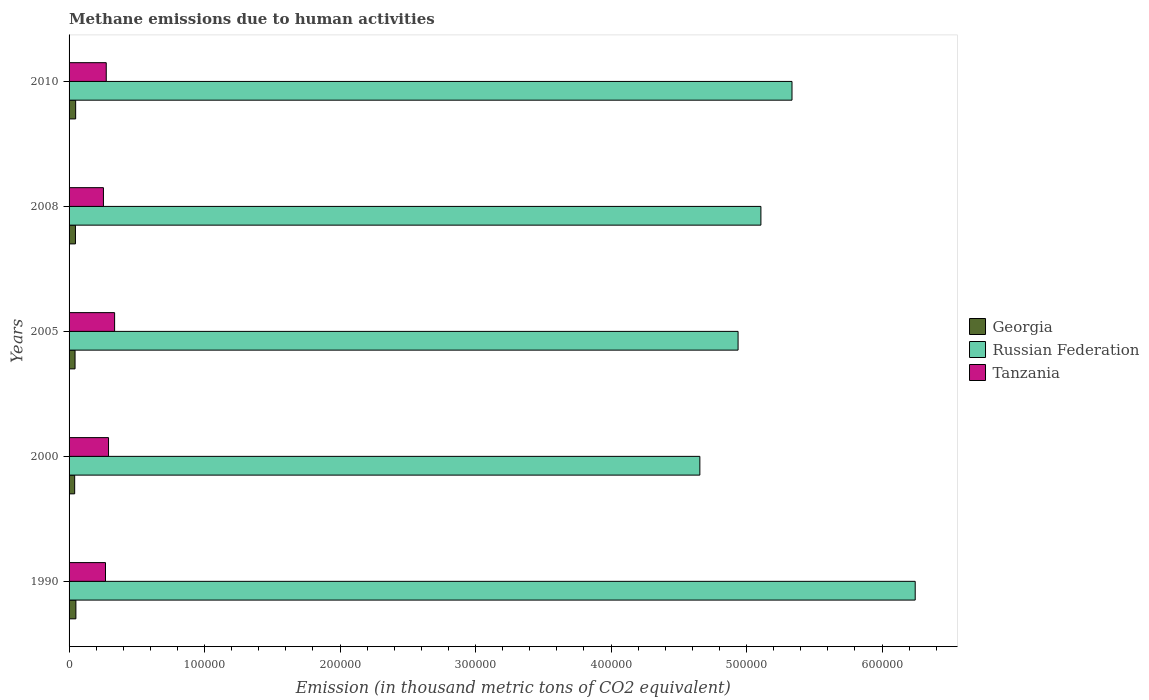How many groups of bars are there?
Offer a very short reply. 5. How many bars are there on the 5th tick from the top?
Give a very brief answer. 3. What is the amount of methane emitted in Russian Federation in 2005?
Provide a short and direct response. 4.94e+05. Across all years, what is the maximum amount of methane emitted in Georgia?
Provide a succinct answer. 5037. Across all years, what is the minimum amount of methane emitted in Georgia?
Offer a terse response. 4137.4. In which year was the amount of methane emitted in Tanzania maximum?
Provide a short and direct response. 2005. In which year was the amount of methane emitted in Russian Federation minimum?
Offer a very short reply. 2000. What is the total amount of methane emitted in Tanzania in the graph?
Offer a very short reply. 1.42e+05. What is the difference between the amount of methane emitted in Tanzania in 1990 and that in 2005?
Your response must be concise. -6719. What is the difference between the amount of methane emitted in Tanzania in 2005 and the amount of methane emitted in Georgia in 2000?
Offer a very short reply. 2.95e+04. What is the average amount of methane emitted in Tanzania per year?
Your answer should be very brief. 2.85e+04. In the year 2000, what is the difference between the amount of methane emitted in Tanzania and amount of methane emitted in Russian Federation?
Offer a terse response. -4.36e+05. In how many years, is the amount of methane emitted in Georgia greater than 340000 thousand metric tons?
Keep it short and to the point. 0. What is the ratio of the amount of methane emitted in Russian Federation in 1990 to that in 2008?
Provide a succinct answer. 1.22. Is the amount of methane emitted in Tanzania in 2000 less than that in 2005?
Your response must be concise. Yes. Is the difference between the amount of methane emitted in Tanzania in 2005 and 2010 greater than the difference between the amount of methane emitted in Russian Federation in 2005 and 2010?
Offer a very short reply. Yes. What is the difference between the highest and the second highest amount of methane emitted in Georgia?
Make the answer very short. 173.5. What is the difference between the highest and the lowest amount of methane emitted in Georgia?
Make the answer very short. 899.6. In how many years, is the amount of methane emitted in Russian Federation greater than the average amount of methane emitted in Russian Federation taken over all years?
Make the answer very short. 2. Is the sum of the amount of methane emitted in Russian Federation in 2000 and 2010 greater than the maximum amount of methane emitted in Tanzania across all years?
Your answer should be compact. Yes. What does the 3rd bar from the top in 2005 represents?
Offer a terse response. Georgia. What does the 3rd bar from the bottom in 2000 represents?
Your answer should be very brief. Tanzania. Is it the case that in every year, the sum of the amount of methane emitted in Tanzania and amount of methane emitted in Russian Federation is greater than the amount of methane emitted in Georgia?
Keep it short and to the point. Yes. How many years are there in the graph?
Provide a succinct answer. 5. Does the graph contain any zero values?
Keep it short and to the point. No. Does the graph contain grids?
Give a very brief answer. No. How many legend labels are there?
Keep it short and to the point. 3. What is the title of the graph?
Your answer should be compact. Methane emissions due to human activities. What is the label or title of the X-axis?
Offer a terse response. Emission (in thousand metric tons of CO2 equivalent). What is the Emission (in thousand metric tons of CO2 equivalent) of Georgia in 1990?
Your answer should be very brief. 5037. What is the Emission (in thousand metric tons of CO2 equivalent) of Russian Federation in 1990?
Give a very brief answer. 6.24e+05. What is the Emission (in thousand metric tons of CO2 equivalent) in Tanzania in 1990?
Your answer should be very brief. 2.69e+04. What is the Emission (in thousand metric tons of CO2 equivalent) in Georgia in 2000?
Your answer should be very brief. 4137.4. What is the Emission (in thousand metric tons of CO2 equivalent) of Russian Federation in 2000?
Offer a very short reply. 4.66e+05. What is the Emission (in thousand metric tons of CO2 equivalent) of Tanzania in 2000?
Provide a short and direct response. 2.91e+04. What is the Emission (in thousand metric tons of CO2 equivalent) of Georgia in 2005?
Your answer should be compact. 4413.2. What is the Emission (in thousand metric tons of CO2 equivalent) of Russian Federation in 2005?
Offer a very short reply. 4.94e+05. What is the Emission (in thousand metric tons of CO2 equivalent) of Tanzania in 2005?
Ensure brevity in your answer.  3.36e+04. What is the Emission (in thousand metric tons of CO2 equivalent) of Georgia in 2008?
Give a very brief answer. 4708.2. What is the Emission (in thousand metric tons of CO2 equivalent) in Russian Federation in 2008?
Keep it short and to the point. 5.11e+05. What is the Emission (in thousand metric tons of CO2 equivalent) of Tanzania in 2008?
Make the answer very short. 2.54e+04. What is the Emission (in thousand metric tons of CO2 equivalent) of Georgia in 2010?
Give a very brief answer. 4863.5. What is the Emission (in thousand metric tons of CO2 equivalent) of Russian Federation in 2010?
Your answer should be compact. 5.34e+05. What is the Emission (in thousand metric tons of CO2 equivalent) of Tanzania in 2010?
Ensure brevity in your answer.  2.74e+04. Across all years, what is the maximum Emission (in thousand metric tons of CO2 equivalent) of Georgia?
Give a very brief answer. 5037. Across all years, what is the maximum Emission (in thousand metric tons of CO2 equivalent) of Russian Federation?
Offer a terse response. 6.24e+05. Across all years, what is the maximum Emission (in thousand metric tons of CO2 equivalent) of Tanzania?
Your answer should be very brief. 3.36e+04. Across all years, what is the minimum Emission (in thousand metric tons of CO2 equivalent) of Georgia?
Your answer should be compact. 4137.4. Across all years, what is the minimum Emission (in thousand metric tons of CO2 equivalent) of Russian Federation?
Your answer should be compact. 4.66e+05. Across all years, what is the minimum Emission (in thousand metric tons of CO2 equivalent) of Tanzania?
Make the answer very short. 2.54e+04. What is the total Emission (in thousand metric tons of CO2 equivalent) of Georgia in the graph?
Your response must be concise. 2.32e+04. What is the total Emission (in thousand metric tons of CO2 equivalent) in Russian Federation in the graph?
Provide a short and direct response. 2.63e+06. What is the total Emission (in thousand metric tons of CO2 equivalent) in Tanzania in the graph?
Keep it short and to the point. 1.42e+05. What is the difference between the Emission (in thousand metric tons of CO2 equivalent) of Georgia in 1990 and that in 2000?
Offer a terse response. 899.6. What is the difference between the Emission (in thousand metric tons of CO2 equivalent) in Russian Federation in 1990 and that in 2000?
Offer a terse response. 1.59e+05. What is the difference between the Emission (in thousand metric tons of CO2 equivalent) in Tanzania in 1990 and that in 2000?
Your answer should be very brief. -2232.7. What is the difference between the Emission (in thousand metric tons of CO2 equivalent) in Georgia in 1990 and that in 2005?
Your response must be concise. 623.8. What is the difference between the Emission (in thousand metric tons of CO2 equivalent) of Russian Federation in 1990 and that in 2005?
Offer a very short reply. 1.31e+05. What is the difference between the Emission (in thousand metric tons of CO2 equivalent) of Tanzania in 1990 and that in 2005?
Offer a terse response. -6719. What is the difference between the Emission (in thousand metric tons of CO2 equivalent) of Georgia in 1990 and that in 2008?
Your answer should be compact. 328.8. What is the difference between the Emission (in thousand metric tons of CO2 equivalent) in Russian Federation in 1990 and that in 2008?
Provide a short and direct response. 1.14e+05. What is the difference between the Emission (in thousand metric tons of CO2 equivalent) of Tanzania in 1990 and that in 2008?
Ensure brevity in your answer.  1531.3. What is the difference between the Emission (in thousand metric tons of CO2 equivalent) in Georgia in 1990 and that in 2010?
Provide a short and direct response. 173.5. What is the difference between the Emission (in thousand metric tons of CO2 equivalent) of Russian Federation in 1990 and that in 2010?
Give a very brief answer. 9.09e+04. What is the difference between the Emission (in thousand metric tons of CO2 equivalent) of Tanzania in 1990 and that in 2010?
Your answer should be compact. -554.2. What is the difference between the Emission (in thousand metric tons of CO2 equivalent) in Georgia in 2000 and that in 2005?
Your answer should be compact. -275.8. What is the difference between the Emission (in thousand metric tons of CO2 equivalent) of Russian Federation in 2000 and that in 2005?
Make the answer very short. -2.82e+04. What is the difference between the Emission (in thousand metric tons of CO2 equivalent) of Tanzania in 2000 and that in 2005?
Your response must be concise. -4486.3. What is the difference between the Emission (in thousand metric tons of CO2 equivalent) of Georgia in 2000 and that in 2008?
Offer a terse response. -570.8. What is the difference between the Emission (in thousand metric tons of CO2 equivalent) in Russian Federation in 2000 and that in 2008?
Your response must be concise. -4.51e+04. What is the difference between the Emission (in thousand metric tons of CO2 equivalent) of Tanzania in 2000 and that in 2008?
Your answer should be compact. 3764. What is the difference between the Emission (in thousand metric tons of CO2 equivalent) in Georgia in 2000 and that in 2010?
Provide a short and direct response. -726.1. What is the difference between the Emission (in thousand metric tons of CO2 equivalent) in Russian Federation in 2000 and that in 2010?
Offer a terse response. -6.80e+04. What is the difference between the Emission (in thousand metric tons of CO2 equivalent) in Tanzania in 2000 and that in 2010?
Provide a succinct answer. 1678.5. What is the difference between the Emission (in thousand metric tons of CO2 equivalent) in Georgia in 2005 and that in 2008?
Provide a succinct answer. -295. What is the difference between the Emission (in thousand metric tons of CO2 equivalent) of Russian Federation in 2005 and that in 2008?
Provide a succinct answer. -1.69e+04. What is the difference between the Emission (in thousand metric tons of CO2 equivalent) of Tanzania in 2005 and that in 2008?
Make the answer very short. 8250.3. What is the difference between the Emission (in thousand metric tons of CO2 equivalent) of Georgia in 2005 and that in 2010?
Your response must be concise. -450.3. What is the difference between the Emission (in thousand metric tons of CO2 equivalent) in Russian Federation in 2005 and that in 2010?
Give a very brief answer. -3.98e+04. What is the difference between the Emission (in thousand metric tons of CO2 equivalent) in Tanzania in 2005 and that in 2010?
Provide a short and direct response. 6164.8. What is the difference between the Emission (in thousand metric tons of CO2 equivalent) of Georgia in 2008 and that in 2010?
Offer a very short reply. -155.3. What is the difference between the Emission (in thousand metric tons of CO2 equivalent) of Russian Federation in 2008 and that in 2010?
Give a very brief answer. -2.29e+04. What is the difference between the Emission (in thousand metric tons of CO2 equivalent) of Tanzania in 2008 and that in 2010?
Your response must be concise. -2085.5. What is the difference between the Emission (in thousand metric tons of CO2 equivalent) of Georgia in 1990 and the Emission (in thousand metric tons of CO2 equivalent) of Russian Federation in 2000?
Offer a very short reply. -4.61e+05. What is the difference between the Emission (in thousand metric tons of CO2 equivalent) of Georgia in 1990 and the Emission (in thousand metric tons of CO2 equivalent) of Tanzania in 2000?
Provide a short and direct response. -2.41e+04. What is the difference between the Emission (in thousand metric tons of CO2 equivalent) in Russian Federation in 1990 and the Emission (in thousand metric tons of CO2 equivalent) in Tanzania in 2000?
Your answer should be very brief. 5.95e+05. What is the difference between the Emission (in thousand metric tons of CO2 equivalent) of Georgia in 1990 and the Emission (in thousand metric tons of CO2 equivalent) of Russian Federation in 2005?
Keep it short and to the point. -4.89e+05. What is the difference between the Emission (in thousand metric tons of CO2 equivalent) of Georgia in 1990 and the Emission (in thousand metric tons of CO2 equivalent) of Tanzania in 2005?
Provide a succinct answer. -2.86e+04. What is the difference between the Emission (in thousand metric tons of CO2 equivalent) in Russian Federation in 1990 and the Emission (in thousand metric tons of CO2 equivalent) in Tanzania in 2005?
Provide a succinct answer. 5.91e+05. What is the difference between the Emission (in thousand metric tons of CO2 equivalent) in Georgia in 1990 and the Emission (in thousand metric tons of CO2 equivalent) in Russian Federation in 2008?
Offer a terse response. -5.06e+05. What is the difference between the Emission (in thousand metric tons of CO2 equivalent) in Georgia in 1990 and the Emission (in thousand metric tons of CO2 equivalent) in Tanzania in 2008?
Make the answer very short. -2.03e+04. What is the difference between the Emission (in thousand metric tons of CO2 equivalent) of Russian Federation in 1990 and the Emission (in thousand metric tons of CO2 equivalent) of Tanzania in 2008?
Your response must be concise. 5.99e+05. What is the difference between the Emission (in thousand metric tons of CO2 equivalent) in Georgia in 1990 and the Emission (in thousand metric tons of CO2 equivalent) in Russian Federation in 2010?
Provide a short and direct response. -5.29e+05. What is the difference between the Emission (in thousand metric tons of CO2 equivalent) in Georgia in 1990 and the Emission (in thousand metric tons of CO2 equivalent) in Tanzania in 2010?
Provide a short and direct response. -2.24e+04. What is the difference between the Emission (in thousand metric tons of CO2 equivalent) of Russian Federation in 1990 and the Emission (in thousand metric tons of CO2 equivalent) of Tanzania in 2010?
Give a very brief answer. 5.97e+05. What is the difference between the Emission (in thousand metric tons of CO2 equivalent) in Georgia in 2000 and the Emission (in thousand metric tons of CO2 equivalent) in Russian Federation in 2005?
Make the answer very short. -4.90e+05. What is the difference between the Emission (in thousand metric tons of CO2 equivalent) in Georgia in 2000 and the Emission (in thousand metric tons of CO2 equivalent) in Tanzania in 2005?
Provide a short and direct response. -2.95e+04. What is the difference between the Emission (in thousand metric tons of CO2 equivalent) in Russian Federation in 2000 and the Emission (in thousand metric tons of CO2 equivalent) in Tanzania in 2005?
Your answer should be very brief. 4.32e+05. What is the difference between the Emission (in thousand metric tons of CO2 equivalent) of Georgia in 2000 and the Emission (in thousand metric tons of CO2 equivalent) of Russian Federation in 2008?
Make the answer very short. -5.06e+05. What is the difference between the Emission (in thousand metric tons of CO2 equivalent) in Georgia in 2000 and the Emission (in thousand metric tons of CO2 equivalent) in Tanzania in 2008?
Provide a succinct answer. -2.12e+04. What is the difference between the Emission (in thousand metric tons of CO2 equivalent) of Russian Federation in 2000 and the Emission (in thousand metric tons of CO2 equivalent) of Tanzania in 2008?
Offer a terse response. 4.40e+05. What is the difference between the Emission (in thousand metric tons of CO2 equivalent) in Georgia in 2000 and the Emission (in thousand metric tons of CO2 equivalent) in Russian Federation in 2010?
Offer a very short reply. -5.29e+05. What is the difference between the Emission (in thousand metric tons of CO2 equivalent) of Georgia in 2000 and the Emission (in thousand metric tons of CO2 equivalent) of Tanzania in 2010?
Your answer should be compact. -2.33e+04. What is the difference between the Emission (in thousand metric tons of CO2 equivalent) in Russian Federation in 2000 and the Emission (in thousand metric tons of CO2 equivalent) in Tanzania in 2010?
Give a very brief answer. 4.38e+05. What is the difference between the Emission (in thousand metric tons of CO2 equivalent) of Georgia in 2005 and the Emission (in thousand metric tons of CO2 equivalent) of Russian Federation in 2008?
Offer a very short reply. -5.06e+05. What is the difference between the Emission (in thousand metric tons of CO2 equivalent) of Georgia in 2005 and the Emission (in thousand metric tons of CO2 equivalent) of Tanzania in 2008?
Keep it short and to the point. -2.09e+04. What is the difference between the Emission (in thousand metric tons of CO2 equivalent) in Russian Federation in 2005 and the Emission (in thousand metric tons of CO2 equivalent) in Tanzania in 2008?
Your answer should be very brief. 4.68e+05. What is the difference between the Emission (in thousand metric tons of CO2 equivalent) of Georgia in 2005 and the Emission (in thousand metric tons of CO2 equivalent) of Russian Federation in 2010?
Offer a terse response. -5.29e+05. What is the difference between the Emission (in thousand metric tons of CO2 equivalent) in Georgia in 2005 and the Emission (in thousand metric tons of CO2 equivalent) in Tanzania in 2010?
Keep it short and to the point. -2.30e+04. What is the difference between the Emission (in thousand metric tons of CO2 equivalent) of Russian Federation in 2005 and the Emission (in thousand metric tons of CO2 equivalent) of Tanzania in 2010?
Keep it short and to the point. 4.66e+05. What is the difference between the Emission (in thousand metric tons of CO2 equivalent) in Georgia in 2008 and the Emission (in thousand metric tons of CO2 equivalent) in Russian Federation in 2010?
Give a very brief answer. -5.29e+05. What is the difference between the Emission (in thousand metric tons of CO2 equivalent) in Georgia in 2008 and the Emission (in thousand metric tons of CO2 equivalent) in Tanzania in 2010?
Keep it short and to the point. -2.27e+04. What is the difference between the Emission (in thousand metric tons of CO2 equivalent) in Russian Federation in 2008 and the Emission (in thousand metric tons of CO2 equivalent) in Tanzania in 2010?
Keep it short and to the point. 4.83e+05. What is the average Emission (in thousand metric tons of CO2 equivalent) of Georgia per year?
Keep it short and to the point. 4631.86. What is the average Emission (in thousand metric tons of CO2 equivalent) of Russian Federation per year?
Give a very brief answer. 5.26e+05. What is the average Emission (in thousand metric tons of CO2 equivalent) of Tanzania per year?
Your answer should be compact. 2.85e+04. In the year 1990, what is the difference between the Emission (in thousand metric tons of CO2 equivalent) of Georgia and Emission (in thousand metric tons of CO2 equivalent) of Russian Federation?
Offer a very short reply. -6.19e+05. In the year 1990, what is the difference between the Emission (in thousand metric tons of CO2 equivalent) of Georgia and Emission (in thousand metric tons of CO2 equivalent) of Tanzania?
Your answer should be compact. -2.19e+04. In the year 1990, what is the difference between the Emission (in thousand metric tons of CO2 equivalent) of Russian Federation and Emission (in thousand metric tons of CO2 equivalent) of Tanzania?
Give a very brief answer. 5.98e+05. In the year 2000, what is the difference between the Emission (in thousand metric tons of CO2 equivalent) in Georgia and Emission (in thousand metric tons of CO2 equivalent) in Russian Federation?
Make the answer very short. -4.61e+05. In the year 2000, what is the difference between the Emission (in thousand metric tons of CO2 equivalent) in Georgia and Emission (in thousand metric tons of CO2 equivalent) in Tanzania?
Offer a very short reply. -2.50e+04. In the year 2000, what is the difference between the Emission (in thousand metric tons of CO2 equivalent) in Russian Federation and Emission (in thousand metric tons of CO2 equivalent) in Tanzania?
Make the answer very short. 4.36e+05. In the year 2005, what is the difference between the Emission (in thousand metric tons of CO2 equivalent) of Georgia and Emission (in thousand metric tons of CO2 equivalent) of Russian Federation?
Your answer should be very brief. -4.89e+05. In the year 2005, what is the difference between the Emission (in thousand metric tons of CO2 equivalent) in Georgia and Emission (in thousand metric tons of CO2 equivalent) in Tanzania?
Provide a succinct answer. -2.92e+04. In the year 2005, what is the difference between the Emission (in thousand metric tons of CO2 equivalent) of Russian Federation and Emission (in thousand metric tons of CO2 equivalent) of Tanzania?
Your response must be concise. 4.60e+05. In the year 2008, what is the difference between the Emission (in thousand metric tons of CO2 equivalent) in Georgia and Emission (in thousand metric tons of CO2 equivalent) in Russian Federation?
Offer a terse response. -5.06e+05. In the year 2008, what is the difference between the Emission (in thousand metric tons of CO2 equivalent) of Georgia and Emission (in thousand metric tons of CO2 equivalent) of Tanzania?
Give a very brief answer. -2.07e+04. In the year 2008, what is the difference between the Emission (in thousand metric tons of CO2 equivalent) in Russian Federation and Emission (in thousand metric tons of CO2 equivalent) in Tanzania?
Make the answer very short. 4.85e+05. In the year 2010, what is the difference between the Emission (in thousand metric tons of CO2 equivalent) in Georgia and Emission (in thousand metric tons of CO2 equivalent) in Russian Federation?
Give a very brief answer. -5.29e+05. In the year 2010, what is the difference between the Emission (in thousand metric tons of CO2 equivalent) in Georgia and Emission (in thousand metric tons of CO2 equivalent) in Tanzania?
Ensure brevity in your answer.  -2.26e+04. In the year 2010, what is the difference between the Emission (in thousand metric tons of CO2 equivalent) of Russian Federation and Emission (in thousand metric tons of CO2 equivalent) of Tanzania?
Provide a succinct answer. 5.06e+05. What is the ratio of the Emission (in thousand metric tons of CO2 equivalent) in Georgia in 1990 to that in 2000?
Make the answer very short. 1.22. What is the ratio of the Emission (in thousand metric tons of CO2 equivalent) in Russian Federation in 1990 to that in 2000?
Give a very brief answer. 1.34. What is the ratio of the Emission (in thousand metric tons of CO2 equivalent) in Tanzania in 1990 to that in 2000?
Your response must be concise. 0.92. What is the ratio of the Emission (in thousand metric tons of CO2 equivalent) in Georgia in 1990 to that in 2005?
Your answer should be compact. 1.14. What is the ratio of the Emission (in thousand metric tons of CO2 equivalent) of Russian Federation in 1990 to that in 2005?
Provide a succinct answer. 1.26. What is the ratio of the Emission (in thousand metric tons of CO2 equivalent) in Tanzania in 1990 to that in 2005?
Offer a terse response. 0.8. What is the ratio of the Emission (in thousand metric tons of CO2 equivalent) in Georgia in 1990 to that in 2008?
Ensure brevity in your answer.  1.07. What is the ratio of the Emission (in thousand metric tons of CO2 equivalent) of Russian Federation in 1990 to that in 2008?
Keep it short and to the point. 1.22. What is the ratio of the Emission (in thousand metric tons of CO2 equivalent) in Tanzania in 1990 to that in 2008?
Your answer should be compact. 1.06. What is the ratio of the Emission (in thousand metric tons of CO2 equivalent) in Georgia in 1990 to that in 2010?
Provide a short and direct response. 1.04. What is the ratio of the Emission (in thousand metric tons of CO2 equivalent) of Russian Federation in 1990 to that in 2010?
Your answer should be compact. 1.17. What is the ratio of the Emission (in thousand metric tons of CO2 equivalent) in Tanzania in 1990 to that in 2010?
Give a very brief answer. 0.98. What is the ratio of the Emission (in thousand metric tons of CO2 equivalent) of Russian Federation in 2000 to that in 2005?
Keep it short and to the point. 0.94. What is the ratio of the Emission (in thousand metric tons of CO2 equivalent) in Tanzania in 2000 to that in 2005?
Make the answer very short. 0.87. What is the ratio of the Emission (in thousand metric tons of CO2 equivalent) of Georgia in 2000 to that in 2008?
Ensure brevity in your answer.  0.88. What is the ratio of the Emission (in thousand metric tons of CO2 equivalent) in Russian Federation in 2000 to that in 2008?
Your answer should be very brief. 0.91. What is the ratio of the Emission (in thousand metric tons of CO2 equivalent) of Tanzania in 2000 to that in 2008?
Your answer should be very brief. 1.15. What is the ratio of the Emission (in thousand metric tons of CO2 equivalent) of Georgia in 2000 to that in 2010?
Make the answer very short. 0.85. What is the ratio of the Emission (in thousand metric tons of CO2 equivalent) in Russian Federation in 2000 to that in 2010?
Your response must be concise. 0.87. What is the ratio of the Emission (in thousand metric tons of CO2 equivalent) in Tanzania in 2000 to that in 2010?
Provide a succinct answer. 1.06. What is the ratio of the Emission (in thousand metric tons of CO2 equivalent) in Georgia in 2005 to that in 2008?
Keep it short and to the point. 0.94. What is the ratio of the Emission (in thousand metric tons of CO2 equivalent) of Russian Federation in 2005 to that in 2008?
Ensure brevity in your answer.  0.97. What is the ratio of the Emission (in thousand metric tons of CO2 equivalent) of Tanzania in 2005 to that in 2008?
Make the answer very short. 1.33. What is the ratio of the Emission (in thousand metric tons of CO2 equivalent) of Georgia in 2005 to that in 2010?
Your response must be concise. 0.91. What is the ratio of the Emission (in thousand metric tons of CO2 equivalent) of Russian Federation in 2005 to that in 2010?
Give a very brief answer. 0.93. What is the ratio of the Emission (in thousand metric tons of CO2 equivalent) of Tanzania in 2005 to that in 2010?
Your answer should be compact. 1.22. What is the ratio of the Emission (in thousand metric tons of CO2 equivalent) in Georgia in 2008 to that in 2010?
Offer a terse response. 0.97. What is the ratio of the Emission (in thousand metric tons of CO2 equivalent) in Russian Federation in 2008 to that in 2010?
Ensure brevity in your answer.  0.96. What is the ratio of the Emission (in thousand metric tons of CO2 equivalent) in Tanzania in 2008 to that in 2010?
Ensure brevity in your answer.  0.92. What is the difference between the highest and the second highest Emission (in thousand metric tons of CO2 equivalent) in Georgia?
Your answer should be compact. 173.5. What is the difference between the highest and the second highest Emission (in thousand metric tons of CO2 equivalent) of Russian Federation?
Offer a terse response. 9.09e+04. What is the difference between the highest and the second highest Emission (in thousand metric tons of CO2 equivalent) of Tanzania?
Offer a terse response. 4486.3. What is the difference between the highest and the lowest Emission (in thousand metric tons of CO2 equivalent) in Georgia?
Make the answer very short. 899.6. What is the difference between the highest and the lowest Emission (in thousand metric tons of CO2 equivalent) of Russian Federation?
Offer a very short reply. 1.59e+05. What is the difference between the highest and the lowest Emission (in thousand metric tons of CO2 equivalent) of Tanzania?
Provide a succinct answer. 8250.3. 